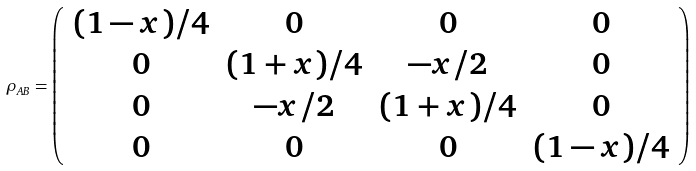<formula> <loc_0><loc_0><loc_500><loc_500>\rho _ { A B } = \left ( \begin{array} { c c c c } { ( 1 - x ) / 4 } & 0 & 0 & 0 \\ 0 & { ( 1 + x ) / 4 } & { - x / 2 } & 0 \\ 0 & { - x / 2 } & { ( 1 + x ) / 4 } & 0 \\ 0 & 0 & 0 & { ( 1 - x ) / 4 } \end{array} \right )</formula> 